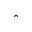Convert formula to latex. <formula><loc_0><loc_0><loc_500><loc_500>\hat { \theta }</formula> 